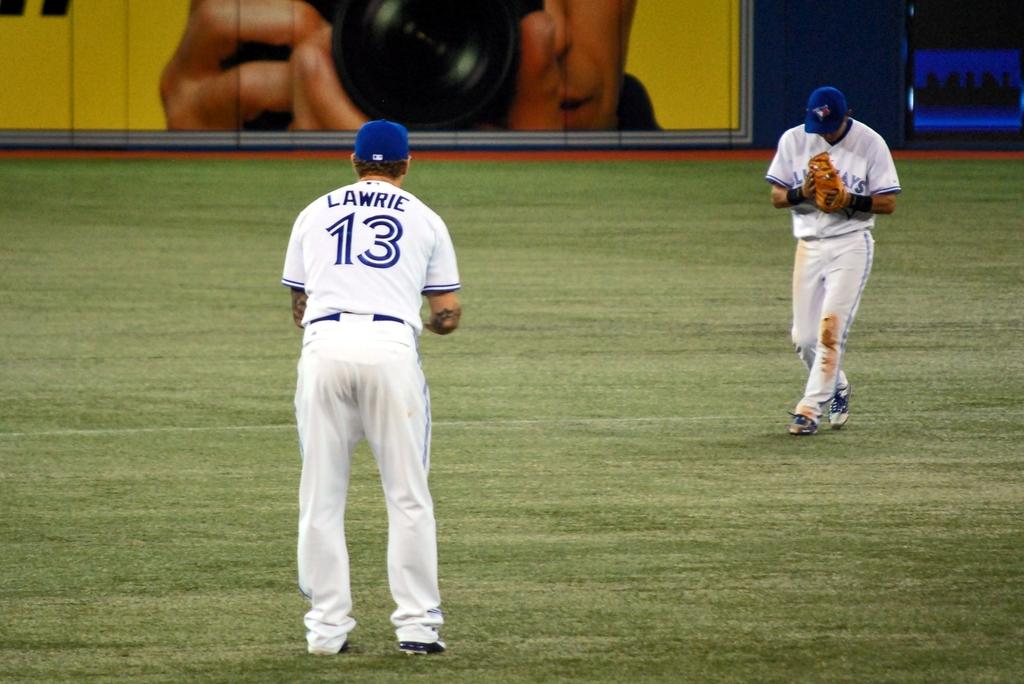What is #13's last name?
Your answer should be very brief. Lawrie. 